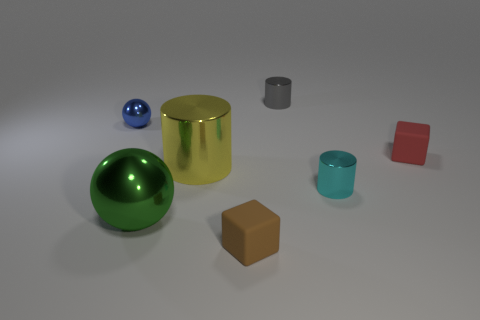Are there any metal objects of the same color as the large cylinder? After careful examination of the image, it appears that there are no metal objects sharing the exact hue or finish of the large gold-colored cylinder. The objects that accompany the cylinder have varying colors and finishes that distinguish them from each other. 